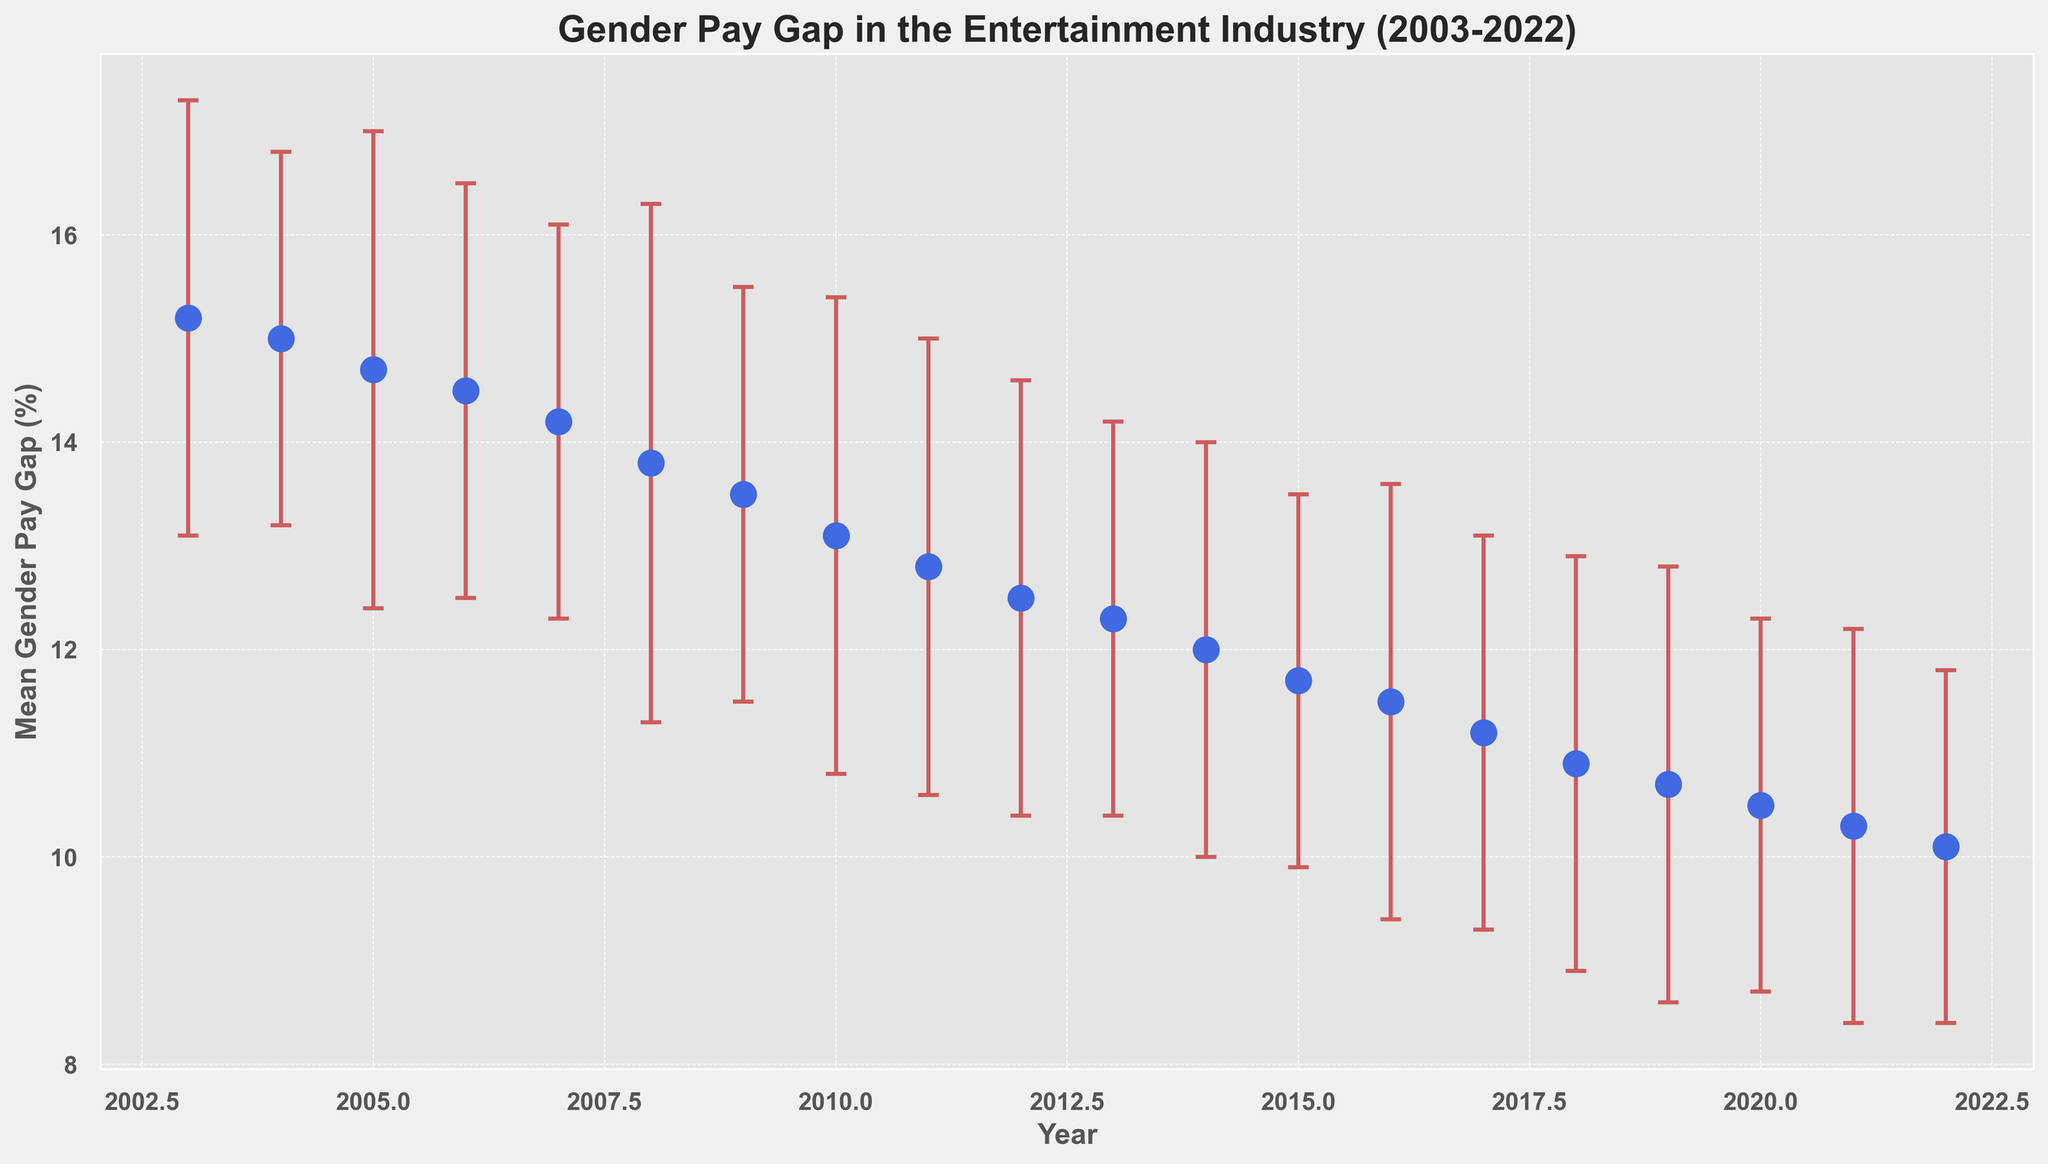What’s the overall trend in the gender pay gap from 2003 to 2022? The trend indicates a consistent decrease in the mean gender pay gap over the years. Initially, in 2003 the gap was at 15.2%, and it steadily decreased to 10.1% in 2022.
Answer: There’s a steady decrease In which year was the mean gender pay gap the highest? To identify the highest point, look for the peak value in the mean gender pay gaps across the years. The highest value is 15.2% in 2003.
Answer: 2003 How does the mean gender pay gap in 2022 compare to that of 2012? In 2022, the mean gender pay gap was 10.1%, whereas, in 2012, it was 12.5%. By comparing both values, we can see that the gap in 2022 is smaller.
Answer: 2022 has a smaller gap Between which consecutive years did the mean gender pay gap decrease the most substantially? To find the most substantial decrease, calculate the difference in the mean gender pay gaps for consecutive years. The largest decrease happened from 2003 to 2004, where the gap reduced from 15.2% to 15.0% by 0.2%.
Answer: 2003 to 2004 What is the approximate range of the mean gender pay gap standard deviations over the years? The smallest standard deviation is 1.7% (2022) and the largest is 2.5% (2008). Subtract 1.7% from 2.5% to get the range.
Answer: 0.8% How did the mean gender pay gap change from 2016 to 2018? In 2016, the gap was 11.5% and in 2018, it was 10.9%. Subtract 10.9% from 11.5% to find the change: 11.5% - 10.9% = 0.6%.
Answer: Decreased by 0.6% What can you infer from the error bars in the figure? Error bars represent the standard deviation around the mean gender pay gap. Wider error bars indicate more variability in the data for that year, while shorter ones indicate less variability. Most errors are fairly consistent but with slight fluctuation.
Answer: Variability is fairly consistent Which year(s) showed a negligible change in mean gender pay gap compared to its previous year? Compare each year with the previous one. Years 2007-2006 (14.2% - 14.5% = 0.3%) and 2015-2014 (11.7% - 12.0% = 0.3%) both show relatively negligible changes
Answer: 2007 and 2015 